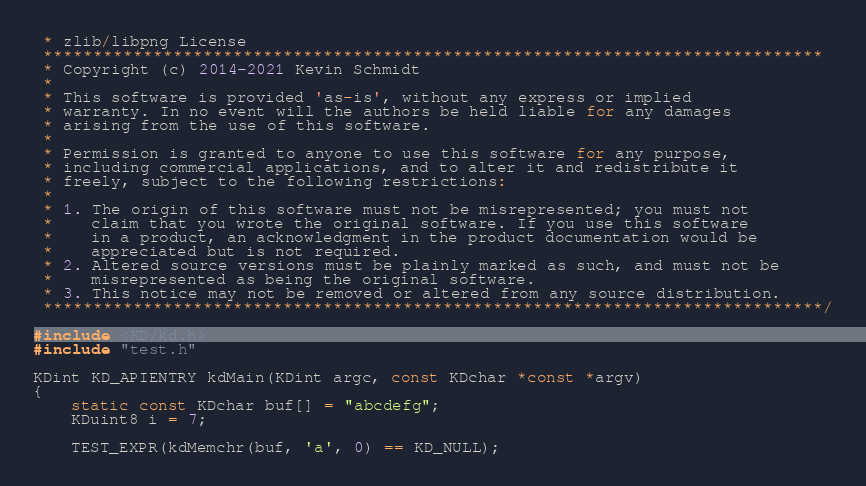Convert code to text. <code><loc_0><loc_0><loc_500><loc_500><_C_> * zlib/libpng License
 ******************************************************************************
 * Copyright (c) 2014-2021 Kevin Schmidt
 *
 * This software is provided 'as-is', without any express or implied
 * warranty. In no event will the authors be held liable for any damages
 * arising from the use of this software.
 *
 * Permission is granted to anyone to use this software for any purpose,
 * including commercial applications, and to alter it and redistribute it
 * freely, subject to the following restrictions:
 *
 * 1. The origin of this software must not be misrepresented; you must not
 *    claim that you wrote the original software. If you use this software
 *    in a product, an acknowledgment in the product documentation would be
 *    appreciated but is not required.
 * 2. Altered source versions must be plainly marked as such, and must not be
 *    misrepresented as being the original software.
 * 3. This notice may not be removed or altered from any source distribution.
 ******************************************************************************/

#include <KD/kd.h>
#include "test.h"

KDint KD_APIENTRY kdMain(KDint argc, const KDchar *const *argv)
{
    static const KDchar buf[] = "abcdefg";
    KDuint8 i = 7;

    TEST_EXPR(kdMemchr(buf, 'a', 0) == KD_NULL);</code> 